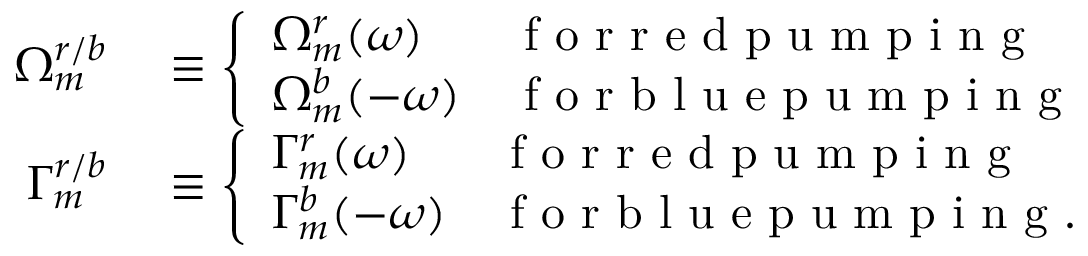<formula> <loc_0><loc_0><loc_500><loc_500>\begin{array} { r l } { \Omega _ { m } ^ { r / b } } & \equiv \left \{ \begin{array} { l l } { \Omega _ { m } ^ { r } ( \omega ) } & { f o r r e d p u m p i n g } \\ { \Omega _ { m } ^ { b } ( - \omega ) } & { f o r b l u e p u m p i n g } \end{array} } \\ { \Gamma _ { m } ^ { r / b } } & \equiv \left \{ \begin{array} { l l } { \Gamma _ { m } ^ { r } ( \omega ) } & { f o r r e d p u m p i n g } \\ { \Gamma _ { m } ^ { b } ( - \omega ) } & { f o r b l u e p u m p i n g . } \end{array} } \end{array}</formula> 